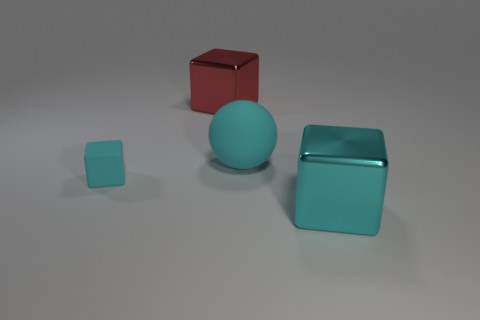What might be the material of the objects, judging by their appearance? Judging by their appearance, all the objects seem to have a matte finish, except the red cube, which has a glossy surface. This suggests they could be made of plastic or a similar material, with the finish affecting the perception of their texture. 